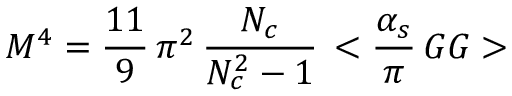Convert formula to latex. <formula><loc_0><loc_0><loc_500><loc_500>M ^ { 4 } = { \frac { 1 1 } { 9 } } \, \pi ^ { 2 } \, { \frac { N _ { c } } { N _ { c } ^ { 2 } - 1 } } \, < { { \frac { \alpha _ { s } } { \pi } } \, G G } ></formula> 